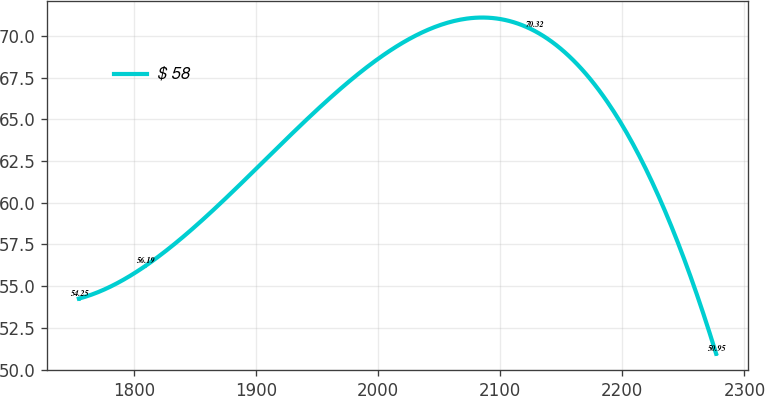<chart> <loc_0><loc_0><loc_500><loc_500><line_chart><ecel><fcel>$ 58<nl><fcel>1755.02<fcel>54.25<nl><fcel>1809.15<fcel>56.19<nl><fcel>2127.55<fcel>70.32<nl><fcel>2276.84<fcel>50.95<nl></chart> 